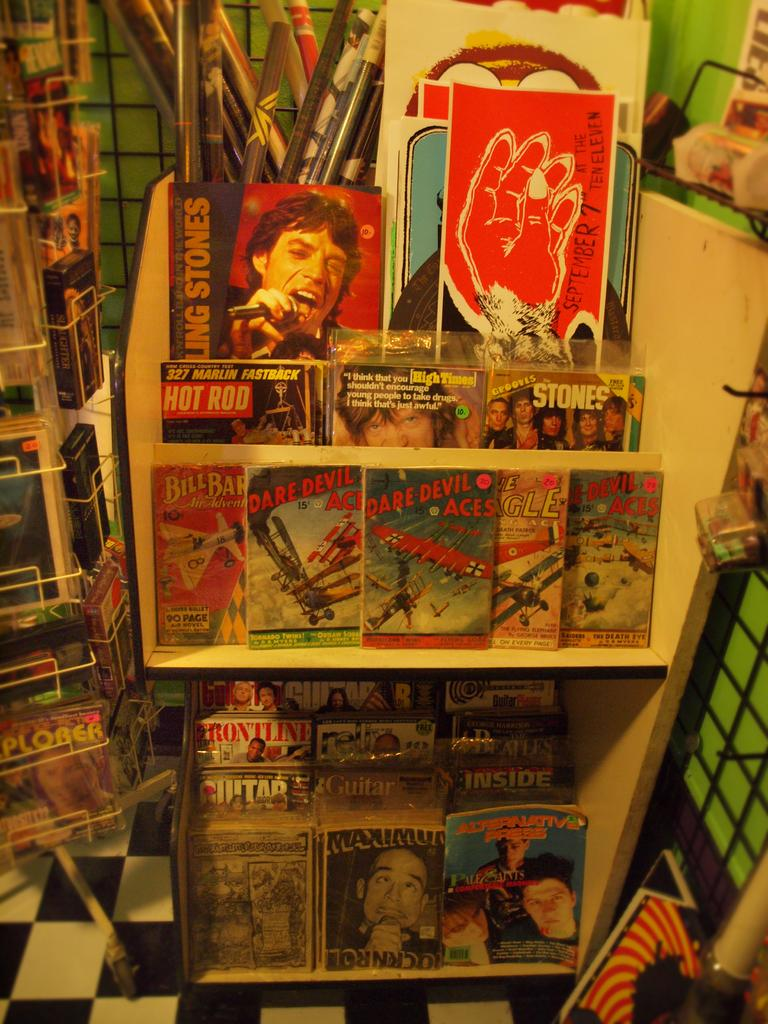<image>
Offer a succinct explanation of the picture presented. A magazine with the title DARE DEVIL ACES is on a stand with other magazines. 